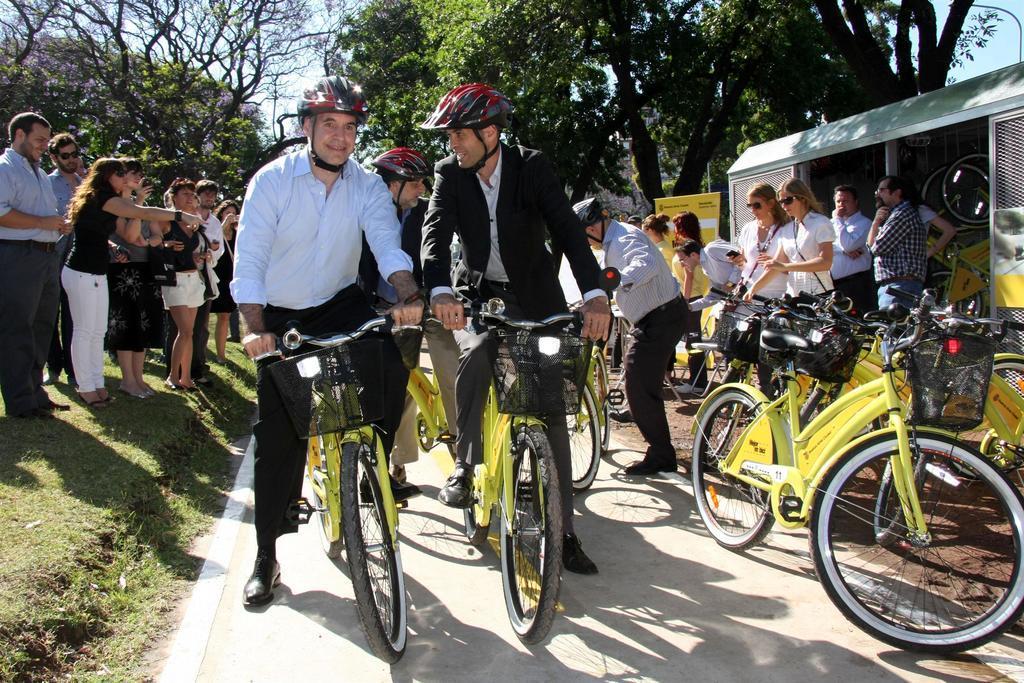Could you give a brief overview of what you see in this image? In this image I see 2 men who are on the cycle and they are on the path and I also see that there are many cycles over here. In the background I see lot of people and lot of trees. 